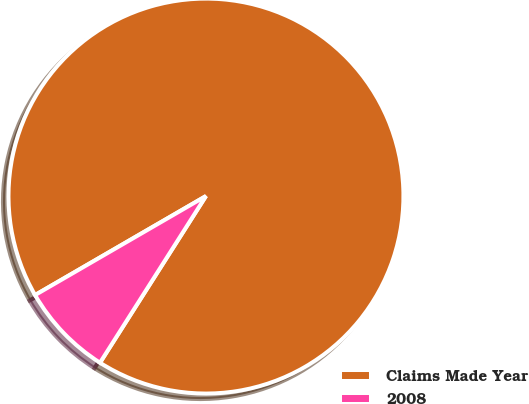Convert chart. <chart><loc_0><loc_0><loc_500><loc_500><pie_chart><fcel>Claims Made Year<fcel>2008<nl><fcel>92.37%<fcel>7.63%<nl></chart> 